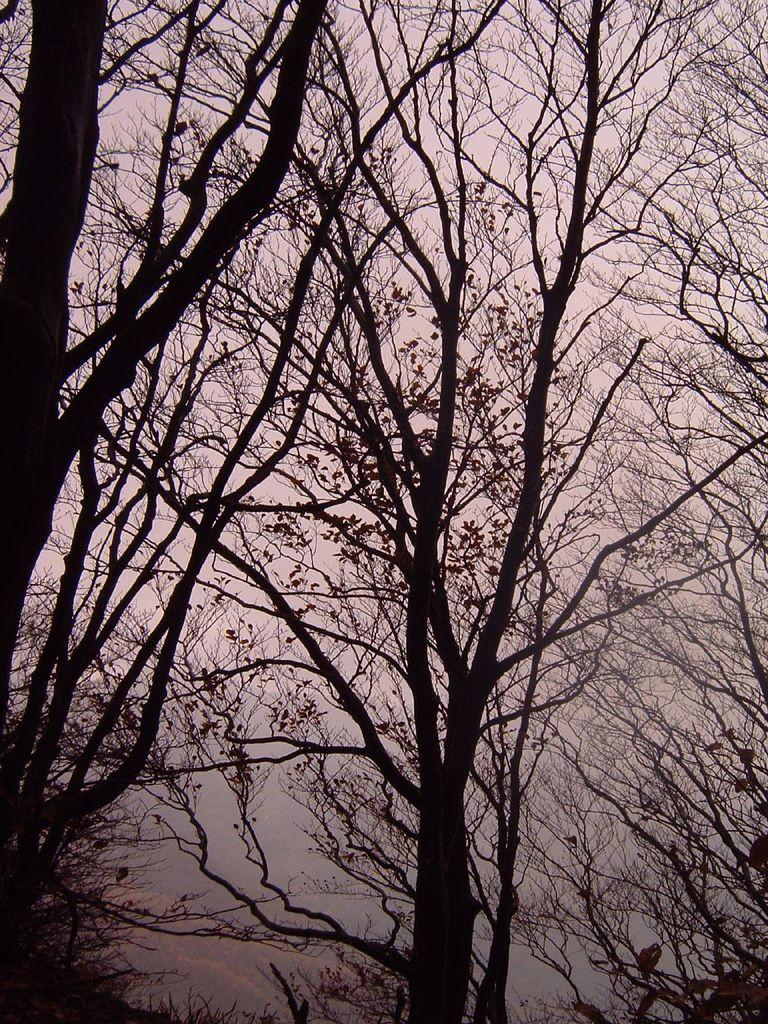What type of vegetation can be seen in the image? There are branches of trees in the image. What part of the tree is visible in the image? The bark of trees is visible in the image. What is visible in the background of the image? The sky is visible in the image. How would you describe the weather based on the sky in the image? The sky appears cloudy in the image, suggesting a potentially overcast or rainy day. What type of error can be seen in the image? There is no error present in the image; it features branches and bark of trees, as well as a cloudy sky. Can you see any mountains in the image? There are no mountains visible in the image; it primarily focuses on the trees and sky. 